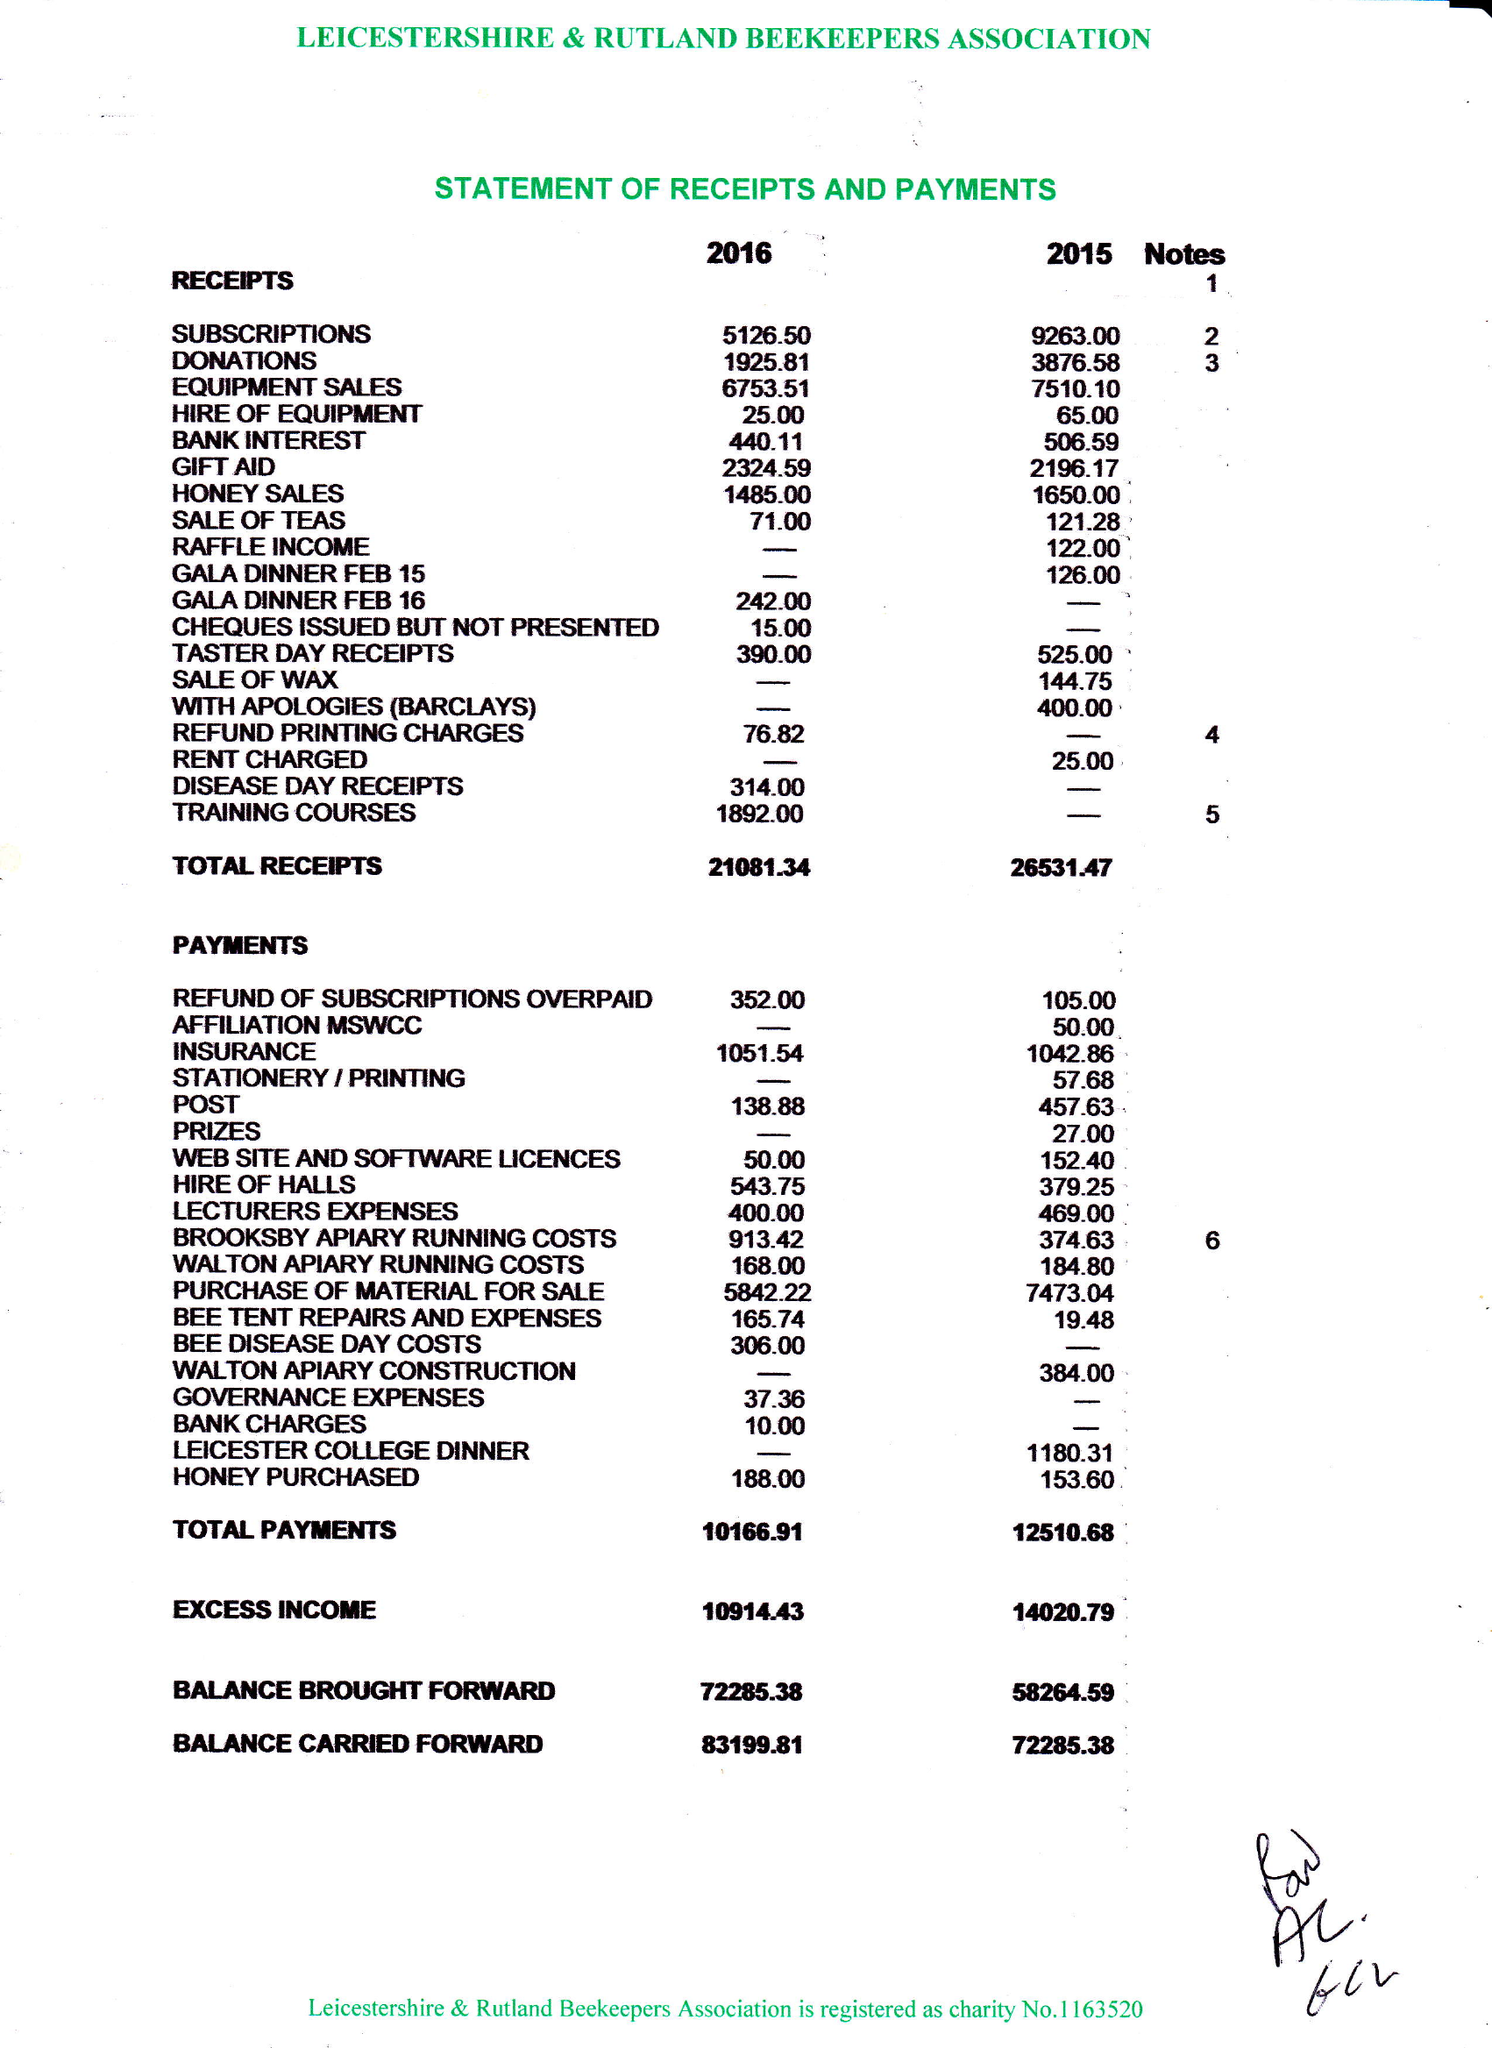What is the value for the charity_number?
Answer the question using a single word or phrase. 1163520 